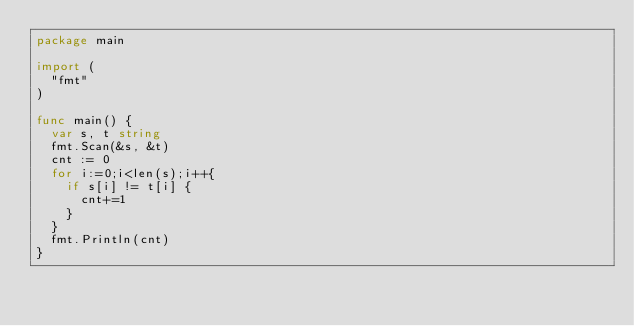<code> <loc_0><loc_0><loc_500><loc_500><_Go_>package main

import (
  "fmt"
)

func main() {
  var s, t string
  fmt.Scan(&s, &t)
  cnt := 0
  for i:=0;i<len(s);i++{
    if s[i] != t[i] {
      cnt+=1
    }
  }
  fmt.Println(cnt)
}</code> 